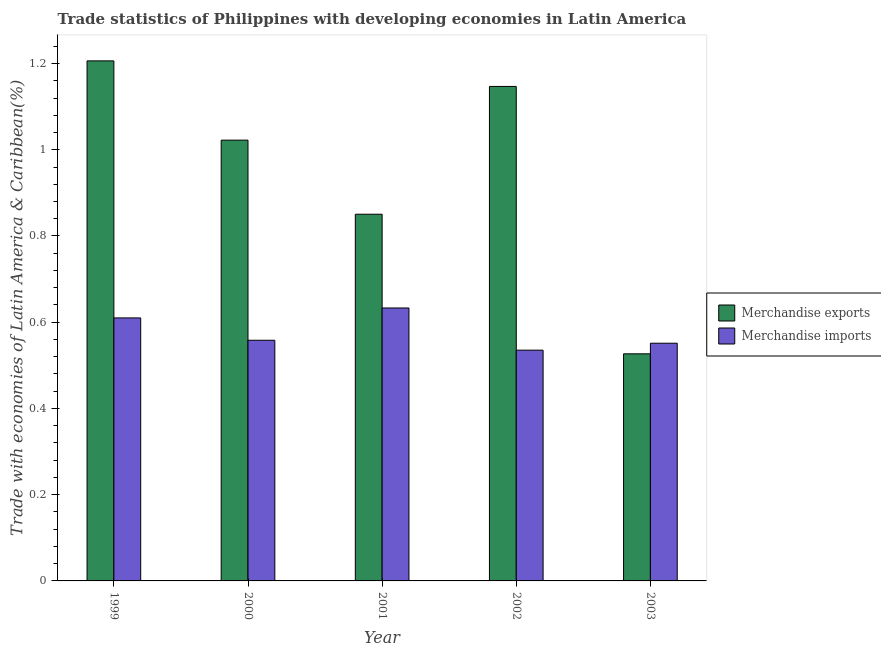How many groups of bars are there?
Provide a succinct answer. 5. Are the number of bars per tick equal to the number of legend labels?
Make the answer very short. Yes. Are the number of bars on each tick of the X-axis equal?
Provide a succinct answer. Yes. How many bars are there on the 4th tick from the right?
Your response must be concise. 2. What is the merchandise exports in 2001?
Your answer should be very brief. 0.85. Across all years, what is the maximum merchandise exports?
Ensure brevity in your answer.  1.21. Across all years, what is the minimum merchandise imports?
Give a very brief answer. 0.54. In which year was the merchandise imports minimum?
Offer a very short reply. 2002. What is the total merchandise imports in the graph?
Make the answer very short. 2.89. What is the difference between the merchandise imports in 2002 and that in 2003?
Keep it short and to the point. -0.02. What is the difference between the merchandise imports in 2000 and the merchandise exports in 2003?
Keep it short and to the point. 0.01. What is the average merchandise imports per year?
Provide a short and direct response. 0.58. What is the ratio of the merchandise imports in 2002 to that in 2003?
Offer a very short reply. 0.97. Is the difference between the merchandise imports in 2002 and 2003 greater than the difference between the merchandise exports in 2002 and 2003?
Make the answer very short. No. What is the difference between the highest and the second highest merchandise imports?
Your response must be concise. 0.02. What is the difference between the highest and the lowest merchandise exports?
Offer a terse response. 0.68. In how many years, is the merchandise exports greater than the average merchandise exports taken over all years?
Offer a terse response. 3. Is the sum of the merchandise imports in 1999 and 2003 greater than the maximum merchandise exports across all years?
Your answer should be very brief. Yes. What does the 1st bar from the right in 2002 represents?
Your answer should be very brief. Merchandise imports. How many bars are there?
Your answer should be compact. 10. Are all the bars in the graph horizontal?
Keep it short and to the point. No. How many years are there in the graph?
Offer a very short reply. 5. Does the graph contain grids?
Keep it short and to the point. No. How many legend labels are there?
Provide a short and direct response. 2. What is the title of the graph?
Offer a terse response. Trade statistics of Philippines with developing economies in Latin America. What is the label or title of the Y-axis?
Your answer should be very brief. Trade with economies of Latin America & Caribbean(%). What is the Trade with economies of Latin America & Caribbean(%) in Merchandise exports in 1999?
Your answer should be compact. 1.21. What is the Trade with economies of Latin America & Caribbean(%) in Merchandise imports in 1999?
Your answer should be very brief. 0.61. What is the Trade with economies of Latin America & Caribbean(%) in Merchandise exports in 2000?
Keep it short and to the point. 1.02. What is the Trade with economies of Latin America & Caribbean(%) in Merchandise imports in 2000?
Your answer should be compact. 0.56. What is the Trade with economies of Latin America & Caribbean(%) in Merchandise exports in 2001?
Keep it short and to the point. 0.85. What is the Trade with economies of Latin America & Caribbean(%) of Merchandise imports in 2001?
Make the answer very short. 0.63. What is the Trade with economies of Latin America & Caribbean(%) in Merchandise exports in 2002?
Offer a terse response. 1.15. What is the Trade with economies of Latin America & Caribbean(%) of Merchandise imports in 2002?
Provide a short and direct response. 0.54. What is the Trade with economies of Latin America & Caribbean(%) of Merchandise exports in 2003?
Make the answer very short. 0.53. What is the Trade with economies of Latin America & Caribbean(%) of Merchandise imports in 2003?
Your answer should be very brief. 0.55. Across all years, what is the maximum Trade with economies of Latin America & Caribbean(%) in Merchandise exports?
Give a very brief answer. 1.21. Across all years, what is the maximum Trade with economies of Latin America & Caribbean(%) of Merchandise imports?
Your response must be concise. 0.63. Across all years, what is the minimum Trade with economies of Latin America & Caribbean(%) of Merchandise exports?
Ensure brevity in your answer.  0.53. Across all years, what is the minimum Trade with economies of Latin America & Caribbean(%) in Merchandise imports?
Offer a very short reply. 0.54. What is the total Trade with economies of Latin America & Caribbean(%) in Merchandise exports in the graph?
Offer a very short reply. 4.75. What is the total Trade with economies of Latin America & Caribbean(%) in Merchandise imports in the graph?
Offer a very short reply. 2.89. What is the difference between the Trade with economies of Latin America & Caribbean(%) in Merchandise exports in 1999 and that in 2000?
Ensure brevity in your answer.  0.18. What is the difference between the Trade with economies of Latin America & Caribbean(%) in Merchandise imports in 1999 and that in 2000?
Offer a terse response. 0.05. What is the difference between the Trade with economies of Latin America & Caribbean(%) of Merchandise exports in 1999 and that in 2001?
Make the answer very short. 0.36. What is the difference between the Trade with economies of Latin America & Caribbean(%) in Merchandise imports in 1999 and that in 2001?
Your answer should be very brief. -0.02. What is the difference between the Trade with economies of Latin America & Caribbean(%) of Merchandise exports in 1999 and that in 2002?
Provide a succinct answer. 0.06. What is the difference between the Trade with economies of Latin America & Caribbean(%) in Merchandise imports in 1999 and that in 2002?
Give a very brief answer. 0.07. What is the difference between the Trade with economies of Latin America & Caribbean(%) of Merchandise exports in 1999 and that in 2003?
Offer a very short reply. 0.68. What is the difference between the Trade with economies of Latin America & Caribbean(%) of Merchandise imports in 1999 and that in 2003?
Your answer should be compact. 0.06. What is the difference between the Trade with economies of Latin America & Caribbean(%) of Merchandise exports in 2000 and that in 2001?
Your answer should be very brief. 0.17. What is the difference between the Trade with economies of Latin America & Caribbean(%) in Merchandise imports in 2000 and that in 2001?
Offer a very short reply. -0.07. What is the difference between the Trade with economies of Latin America & Caribbean(%) in Merchandise exports in 2000 and that in 2002?
Your answer should be very brief. -0.12. What is the difference between the Trade with economies of Latin America & Caribbean(%) of Merchandise imports in 2000 and that in 2002?
Give a very brief answer. 0.02. What is the difference between the Trade with economies of Latin America & Caribbean(%) of Merchandise exports in 2000 and that in 2003?
Provide a succinct answer. 0.5. What is the difference between the Trade with economies of Latin America & Caribbean(%) in Merchandise imports in 2000 and that in 2003?
Your answer should be compact. 0.01. What is the difference between the Trade with economies of Latin America & Caribbean(%) of Merchandise exports in 2001 and that in 2002?
Your response must be concise. -0.3. What is the difference between the Trade with economies of Latin America & Caribbean(%) in Merchandise imports in 2001 and that in 2002?
Offer a terse response. 0.1. What is the difference between the Trade with economies of Latin America & Caribbean(%) in Merchandise exports in 2001 and that in 2003?
Provide a short and direct response. 0.32. What is the difference between the Trade with economies of Latin America & Caribbean(%) in Merchandise imports in 2001 and that in 2003?
Keep it short and to the point. 0.08. What is the difference between the Trade with economies of Latin America & Caribbean(%) of Merchandise exports in 2002 and that in 2003?
Your response must be concise. 0.62. What is the difference between the Trade with economies of Latin America & Caribbean(%) of Merchandise imports in 2002 and that in 2003?
Ensure brevity in your answer.  -0.02. What is the difference between the Trade with economies of Latin America & Caribbean(%) of Merchandise exports in 1999 and the Trade with economies of Latin America & Caribbean(%) of Merchandise imports in 2000?
Offer a very short reply. 0.65. What is the difference between the Trade with economies of Latin America & Caribbean(%) of Merchandise exports in 1999 and the Trade with economies of Latin America & Caribbean(%) of Merchandise imports in 2001?
Provide a succinct answer. 0.57. What is the difference between the Trade with economies of Latin America & Caribbean(%) in Merchandise exports in 1999 and the Trade with economies of Latin America & Caribbean(%) in Merchandise imports in 2002?
Provide a short and direct response. 0.67. What is the difference between the Trade with economies of Latin America & Caribbean(%) of Merchandise exports in 1999 and the Trade with economies of Latin America & Caribbean(%) of Merchandise imports in 2003?
Give a very brief answer. 0.65. What is the difference between the Trade with economies of Latin America & Caribbean(%) of Merchandise exports in 2000 and the Trade with economies of Latin America & Caribbean(%) of Merchandise imports in 2001?
Provide a succinct answer. 0.39. What is the difference between the Trade with economies of Latin America & Caribbean(%) in Merchandise exports in 2000 and the Trade with economies of Latin America & Caribbean(%) in Merchandise imports in 2002?
Provide a succinct answer. 0.49. What is the difference between the Trade with economies of Latin America & Caribbean(%) in Merchandise exports in 2000 and the Trade with economies of Latin America & Caribbean(%) in Merchandise imports in 2003?
Give a very brief answer. 0.47. What is the difference between the Trade with economies of Latin America & Caribbean(%) of Merchandise exports in 2001 and the Trade with economies of Latin America & Caribbean(%) of Merchandise imports in 2002?
Your response must be concise. 0.32. What is the difference between the Trade with economies of Latin America & Caribbean(%) in Merchandise exports in 2001 and the Trade with economies of Latin America & Caribbean(%) in Merchandise imports in 2003?
Offer a terse response. 0.3. What is the difference between the Trade with economies of Latin America & Caribbean(%) in Merchandise exports in 2002 and the Trade with economies of Latin America & Caribbean(%) in Merchandise imports in 2003?
Your answer should be very brief. 0.6. What is the average Trade with economies of Latin America & Caribbean(%) of Merchandise exports per year?
Provide a short and direct response. 0.95. What is the average Trade with economies of Latin America & Caribbean(%) of Merchandise imports per year?
Ensure brevity in your answer.  0.58. In the year 1999, what is the difference between the Trade with economies of Latin America & Caribbean(%) of Merchandise exports and Trade with economies of Latin America & Caribbean(%) of Merchandise imports?
Your response must be concise. 0.6. In the year 2000, what is the difference between the Trade with economies of Latin America & Caribbean(%) in Merchandise exports and Trade with economies of Latin America & Caribbean(%) in Merchandise imports?
Your response must be concise. 0.46. In the year 2001, what is the difference between the Trade with economies of Latin America & Caribbean(%) in Merchandise exports and Trade with economies of Latin America & Caribbean(%) in Merchandise imports?
Provide a succinct answer. 0.22. In the year 2002, what is the difference between the Trade with economies of Latin America & Caribbean(%) of Merchandise exports and Trade with economies of Latin America & Caribbean(%) of Merchandise imports?
Provide a short and direct response. 0.61. In the year 2003, what is the difference between the Trade with economies of Latin America & Caribbean(%) in Merchandise exports and Trade with economies of Latin America & Caribbean(%) in Merchandise imports?
Provide a short and direct response. -0.02. What is the ratio of the Trade with economies of Latin America & Caribbean(%) of Merchandise exports in 1999 to that in 2000?
Provide a short and direct response. 1.18. What is the ratio of the Trade with economies of Latin America & Caribbean(%) in Merchandise imports in 1999 to that in 2000?
Offer a terse response. 1.09. What is the ratio of the Trade with economies of Latin America & Caribbean(%) in Merchandise exports in 1999 to that in 2001?
Your response must be concise. 1.42. What is the ratio of the Trade with economies of Latin America & Caribbean(%) in Merchandise imports in 1999 to that in 2001?
Your response must be concise. 0.96. What is the ratio of the Trade with economies of Latin America & Caribbean(%) in Merchandise exports in 1999 to that in 2002?
Provide a succinct answer. 1.05. What is the ratio of the Trade with economies of Latin America & Caribbean(%) in Merchandise imports in 1999 to that in 2002?
Your answer should be compact. 1.14. What is the ratio of the Trade with economies of Latin America & Caribbean(%) in Merchandise exports in 1999 to that in 2003?
Provide a succinct answer. 2.29. What is the ratio of the Trade with economies of Latin America & Caribbean(%) in Merchandise imports in 1999 to that in 2003?
Offer a very short reply. 1.11. What is the ratio of the Trade with economies of Latin America & Caribbean(%) in Merchandise exports in 2000 to that in 2001?
Your answer should be compact. 1.2. What is the ratio of the Trade with economies of Latin America & Caribbean(%) of Merchandise imports in 2000 to that in 2001?
Make the answer very short. 0.88. What is the ratio of the Trade with economies of Latin America & Caribbean(%) in Merchandise exports in 2000 to that in 2002?
Make the answer very short. 0.89. What is the ratio of the Trade with economies of Latin America & Caribbean(%) of Merchandise imports in 2000 to that in 2002?
Ensure brevity in your answer.  1.04. What is the ratio of the Trade with economies of Latin America & Caribbean(%) of Merchandise exports in 2000 to that in 2003?
Give a very brief answer. 1.94. What is the ratio of the Trade with economies of Latin America & Caribbean(%) in Merchandise imports in 2000 to that in 2003?
Ensure brevity in your answer.  1.01. What is the ratio of the Trade with economies of Latin America & Caribbean(%) of Merchandise exports in 2001 to that in 2002?
Your answer should be compact. 0.74. What is the ratio of the Trade with economies of Latin America & Caribbean(%) of Merchandise imports in 2001 to that in 2002?
Make the answer very short. 1.18. What is the ratio of the Trade with economies of Latin America & Caribbean(%) of Merchandise exports in 2001 to that in 2003?
Offer a very short reply. 1.61. What is the ratio of the Trade with economies of Latin America & Caribbean(%) of Merchandise imports in 2001 to that in 2003?
Your response must be concise. 1.15. What is the ratio of the Trade with economies of Latin America & Caribbean(%) in Merchandise exports in 2002 to that in 2003?
Your response must be concise. 2.18. What is the ratio of the Trade with economies of Latin America & Caribbean(%) in Merchandise imports in 2002 to that in 2003?
Provide a succinct answer. 0.97. What is the difference between the highest and the second highest Trade with economies of Latin America & Caribbean(%) of Merchandise exports?
Your answer should be compact. 0.06. What is the difference between the highest and the second highest Trade with economies of Latin America & Caribbean(%) of Merchandise imports?
Offer a very short reply. 0.02. What is the difference between the highest and the lowest Trade with economies of Latin America & Caribbean(%) of Merchandise exports?
Give a very brief answer. 0.68. What is the difference between the highest and the lowest Trade with economies of Latin America & Caribbean(%) in Merchandise imports?
Your answer should be compact. 0.1. 